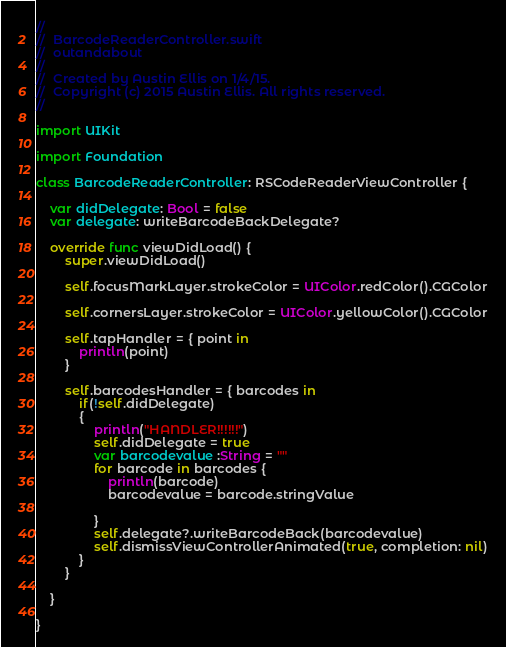Convert code to text. <code><loc_0><loc_0><loc_500><loc_500><_Swift_>//
//  BarcodeReaderController.swift
//  outandabout
//
//  Created by Austin Ellis on 1/4/15.
//  Copyright (c) 2015 Austin Ellis. All rights reserved.
//

import UIKit

import Foundation

class BarcodeReaderController: RSCodeReaderViewController {
    
    var didDelegate: Bool = false
    var delegate: writeBarcodeBackDelegate?
    
    override func viewDidLoad() {
        super.viewDidLoad()
        
        self.focusMarkLayer.strokeColor = UIColor.redColor().CGColor
        
        self.cornersLayer.strokeColor = UIColor.yellowColor().CGColor
        
        self.tapHandler = { point in
            println(point)
        }
        
        self.barcodesHandler = { barcodes in
            if(!self.didDelegate)
            {
                println("HANDLER!!!!!!")
                self.didDelegate = true
                var barcodevalue :String = ""
                for barcode in barcodes {
                    println(barcode)
                    barcodevalue = barcode.stringValue
                    
                }
                self.delegate?.writeBarcodeBack(barcodevalue)
                self.dismissViewControllerAnimated(true, completion: nil)
            }
        }
        
    }
	
}
</code> 